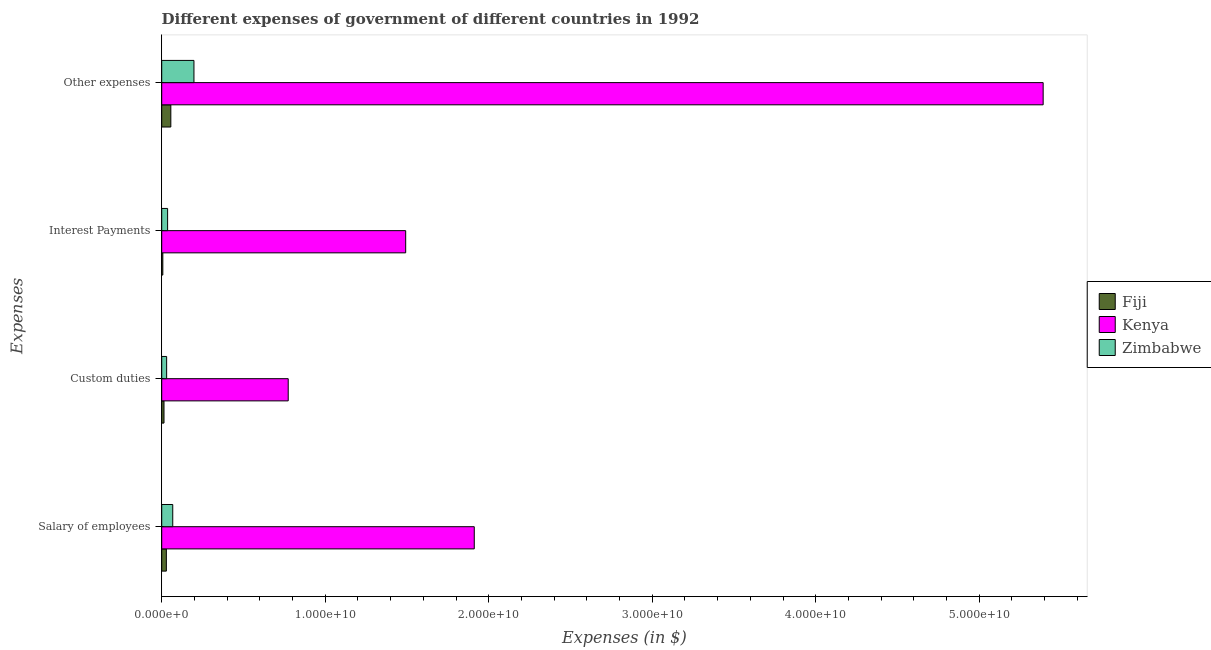How many different coloured bars are there?
Your response must be concise. 3. How many bars are there on the 3rd tick from the top?
Ensure brevity in your answer.  3. How many bars are there on the 4th tick from the bottom?
Provide a short and direct response. 3. What is the label of the 2nd group of bars from the top?
Offer a terse response. Interest Payments. What is the amount spent on other expenses in Fiji?
Your answer should be compact. 5.57e+08. Across all countries, what is the maximum amount spent on salary of employees?
Your response must be concise. 1.91e+1. Across all countries, what is the minimum amount spent on custom duties?
Give a very brief answer. 1.40e+08. In which country was the amount spent on interest payments maximum?
Ensure brevity in your answer.  Kenya. In which country was the amount spent on custom duties minimum?
Make the answer very short. Fiji. What is the total amount spent on salary of employees in the graph?
Your answer should be very brief. 2.01e+1. What is the difference between the amount spent on salary of employees in Zimbabwe and that in Kenya?
Keep it short and to the point. -1.84e+1. What is the difference between the amount spent on salary of employees in Zimbabwe and the amount spent on custom duties in Kenya?
Keep it short and to the point. -7.06e+09. What is the average amount spent on other expenses per country?
Provide a succinct answer. 1.88e+1. What is the difference between the amount spent on interest payments and amount spent on salary of employees in Kenya?
Your answer should be compact. -4.20e+09. In how many countries, is the amount spent on other expenses greater than 28000000000 $?
Give a very brief answer. 1. What is the ratio of the amount spent on salary of employees in Kenya to that in Fiji?
Offer a very short reply. 67.35. What is the difference between the highest and the second highest amount spent on other expenses?
Your answer should be very brief. 5.19e+1. What is the difference between the highest and the lowest amount spent on custom duties?
Your response must be concise. 7.60e+09. Is it the case that in every country, the sum of the amount spent on other expenses and amount spent on custom duties is greater than the sum of amount spent on salary of employees and amount spent on interest payments?
Your answer should be very brief. No. What does the 3rd bar from the top in Other expenses represents?
Offer a very short reply. Fiji. What does the 2nd bar from the bottom in Other expenses represents?
Provide a succinct answer. Kenya. Are all the bars in the graph horizontal?
Your answer should be very brief. Yes. How many countries are there in the graph?
Your answer should be compact. 3. What is the difference between two consecutive major ticks on the X-axis?
Make the answer very short. 1.00e+1. How many legend labels are there?
Your answer should be very brief. 3. How are the legend labels stacked?
Ensure brevity in your answer.  Vertical. What is the title of the graph?
Your answer should be very brief. Different expenses of government of different countries in 1992. What is the label or title of the X-axis?
Ensure brevity in your answer.  Expenses (in $). What is the label or title of the Y-axis?
Offer a very short reply. Expenses. What is the Expenses (in $) of Fiji in Salary of employees?
Provide a succinct answer. 2.84e+08. What is the Expenses (in $) of Kenya in Salary of employees?
Make the answer very short. 1.91e+1. What is the Expenses (in $) of Zimbabwe in Salary of employees?
Make the answer very short. 6.75e+08. What is the Expenses (in $) of Fiji in Custom duties?
Offer a very short reply. 1.40e+08. What is the Expenses (in $) in Kenya in Custom duties?
Provide a short and direct response. 7.74e+09. What is the Expenses (in $) in Zimbabwe in Custom duties?
Ensure brevity in your answer.  3.02e+08. What is the Expenses (in $) in Fiji in Interest Payments?
Give a very brief answer. 6.79e+07. What is the Expenses (in $) in Kenya in Interest Payments?
Keep it short and to the point. 1.49e+1. What is the Expenses (in $) of Zimbabwe in Interest Payments?
Your response must be concise. 3.61e+08. What is the Expenses (in $) of Fiji in Other expenses?
Your answer should be compact. 5.57e+08. What is the Expenses (in $) of Kenya in Other expenses?
Give a very brief answer. 5.39e+1. What is the Expenses (in $) of Zimbabwe in Other expenses?
Offer a very short reply. 1.97e+09. Across all Expenses, what is the maximum Expenses (in $) of Fiji?
Your answer should be very brief. 5.57e+08. Across all Expenses, what is the maximum Expenses (in $) of Kenya?
Ensure brevity in your answer.  5.39e+1. Across all Expenses, what is the maximum Expenses (in $) of Zimbabwe?
Your answer should be very brief. 1.97e+09. Across all Expenses, what is the minimum Expenses (in $) of Fiji?
Offer a very short reply. 6.79e+07. Across all Expenses, what is the minimum Expenses (in $) in Kenya?
Offer a very short reply. 7.74e+09. Across all Expenses, what is the minimum Expenses (in $) in Zimbabwe?
Give a very brief answer. 3.02e+08. What is the total Expenses (in $) in Fiji in the graph?
Your answer should be very brief. 1.05e+09. What is the total Expenses (in $) of Kenya in the graph?
Give a very brief answer. 9.57e+1. What is the total Expenses (in $) of Zimbabwe in the graph?
Offer a very short reply. 3.31e+09. What is the difference between the Expenses (in $) of Fiji in Salary of employees and that in Custom duties?
Offer a terse response. 1.44e+08. What is the difference between the Expenses (in $) of Kenya in Salary of employees and that in Custom duties?
Give a very brief answer. 1.14e+1. What is the difference between the Expenses (in $) in Zimbabwe in Salary of employees and that in Custom duties?
Your response must be concise. 3.73e+08. What is the difference between the Expenses (in $) in Fiji in Salary of employees and that in Interest Payments?
Give a very brief answer. 2.16e+08. What is the difference between the Expenses (in $) in Kenya in Salary of employees and that in Interest Payments?
Provide a succinct answer. 4.20e+09. What is the difference between the Expenses (in $) in Zimbabwe in Salary of employees and that in Interest Payments?
Make the answer very short. 3.14e+08. What is the difference between the Expenses (in $) in Fiji in Salary of employees and that in Other expenses?
Offer a very short reply. -2.74e+08. What is the difference between the Expenses (in $) in Kenya in Salary of employees and that in Other expenses?
Your answer should be very brief. -3.48e+1. What is the difference between the Expenses (in $) in Zimbabwe in Salary of employees and that in Other expenses?
Provide a succinct answer. -1.30e+09. What is the difference between the Expenses (in $) of Fiji in Custom duties and that in Interest Payments?
Ensure brevity in your answer.  7.24e+07. What is the difference between the Expenses (in $) in Kenya in Custom duties and that in Interest Payments?
Offer a very short reply. -7.18e+09. What is the difference between the Expenses (in $) of Zimbabwe in Custom duties and that in Interest Payments?
Provide a short and direct response. -5.88e+07. What is the difference between the Expenses (in $) of Fiji in Custom duties and that in Other expenses?
Offer a very short reply. -4.17e+08. What is the difference between the Expenses (in $) in Kenya in Custom duties and that in Other expenses?
Offer a terse response. -4.62e+1. What is the difference between the Expenses (in $) in Zimbabwe in Custom duties and that in Other expenses?
Your response must be concise. -1.67e+09. What is the difference between the Expenses (in $) of Fiji in Interest Payments and that in Other expenses?
Your answer should be compact. -4.90e+08. What is the difference between the Expenses (in $) in Kenya in Interest Payments and that in Other expenses?
Keep it short and to the point. -3.90e+1. What is the difference between the Expenses (in $) in Zimbabwe in Interest Payments and that in Other expenses?
Give a very brief answer. -1.61e+09. What is the difference between the Expenses (in $) of Fiji in Salary of employees and the Expenses (in $) of Kenya in Custom duties?
Ensure brevity in your answer.  -7.45e+09. What is the difference between the Expenses (in $) of Fiji in Salary of employees and the Expenses (in $) of Zimbabwe in Custom duties?
Your response must be concise. -1.80e+07. What is the difference between the Expenses (in $) in Kenya in Salary of employees and the Expenses (in $) in Zimbabwe in Custom duties?
Your answer should be very brief. 1.88e+1. What is the difference between the Expenses (in $) in Fiji in Salary of employees and the Expenses (in $) in Kenya in Interest Payments?
Make the answer very short. -1.46e+1. What is the difference between the Expenses (in $) in Fiji in Salary of employees and the Expenses (in $) in Zimbabwe in Interest Payments?
Offer a terse response. -7.68e+07. What is the difference between the Expenses (in $) in Kenya in Salary of employees and the Expenses (in $) in Zimbabwe in Interest Payments?
Your answer should be compact. 1.88e+1. What is the difference between the Expenses (in $) of Fiji in Salary of employees and the Expenses (in $) of Kenya in Other expenses?
Keep it short and to the point. -5.36e+1. What is the difference between the Expenses (in $) of Fiji in Salary of employees and the Expenses (in $) of Zimbabwe in Other expenses?
Provide a short and direct response. -1.69e+09. What is the difference between the Expenses (in $) of Kenya in Salary of employees and the Expenses (in $) of Zimbabwe in Other expenses?
Your answer should be compact. 1.71e+1. What is the difference between the Expenses (in $) of Fiji in Custom duties and the Expenses (in $) of Kenya in Interest Payments?
Provide a succinct answer. -1.48e+1. What is the difference between the Expenses (in $) of Fiji in Custom duties and the Expenses (in $) of Zimbabwe in Interest Payments?
Make the answer very short. -2.20e+08. What is the difference between the Expenses (in $) in Kenya in Custom duties and the Expenses (in $) in Zimbabwe in Interest Payments?
Your answer should be compact. 7.38e+09. What is the difference between the Expenses (in $) in Fiji in Custom duties and the Expenses (in $) in Kenya in Other expenses?
Make the answer very short. -5.38e+1. What is the difference between the Expenses (in $) in Fiji in Custom duties and the Expenses (in $) in Zimbabwe in Other expenses?
Make the answer very short. -1.83e+09. What is the difference between the Expenses (in $) in Kenya in Custom duties and the Expenses (in $) in Zimbabwe in Other expenses?
Ensure brevity in your answer.  5.77e+09. What is the difference between the Expenses (in $) in Fiji in Interest Payments and the Expenses (in $) in Kenya in Other expenses?
Ensure brevity in your answer.  -5.38e+1. What is the difference between the Expenses (in $) in Fiji in Interest Payments and the Expenses (in $) in Zimbabwe in Other expenses?
Offer a terse response. -1.90e+09. What is the difference between the Expenses (in $) in Kenya in Interest Payments and the Expenses (in $) in Zimbabwe in Other expenses?
Give a very brief answer. 1.29e+1. What is the average Expenses (in $) in Fiji per Expenses?
Make the answer very short. 2.62e+08. What is the average Expenses (in $) in Kenya per Expenses?
Your answer should be very brief. 2.39e+1. What is the average Expenses (in $) of Zimbabwe per Expenses?
Your answer should be very brief. 8.27e+08. What is the difference between the Expenses (in $) in Fiji and Expenses (in $) in Kenya in Salary of employees?
Offer a terse response. -1.88e+1. What is the difference between the Expenses (in $) in Fiji and Expenses (in $) in Zimbabwe in Salary of employees?
Your answer should be compact. -3.91e+08. What is the difference between the Expenses (in $) of Kenya and Expenses (in $) of Zimbabwe in Salary of employees?
Give a very brief answer. 1.84e+1. What is the difference between the Expenses (in $) in Fiji and Expenses (in $) in Kenya in Custom duties?
Provide a succinct answer. -7.60e+09. What is the difference between the Expenses (in $) in Fiji and Expenses (in $) in Zimbabwe in Custom duties?
Your response must be concise. -1.62e+08. What is the difference between the Expenses (in $) of Kenya and Expenses (in $) of Zimbabwe in Custom duties?
Your response must be concise. 7.44e+09. What is the difference between the Expenses (in $) of Fiji and Expenses (in $) of Kenya in Interest Payments?
Keep it short and to the point. -1.49e+1. What is the difference between the Expenses (in $) in Fiji and Expenses (in $) in Zimbabwe in Interest Payments?
Your response must be concise. -2.93e+08. What is the difference between the Expenses (in $) of Kenya and Expenses (in $) of Zimbabwe in Interest Payments?
Your answer should be very brief. 1.46e+1. What is the difference between the Expenses (in $) in Fiji and Expenses (in $) in Kenya in Other expenses?
Offer a very short reply. -5.34e+1. What is the difference between the Expenses (in $) in Fiji and Expenses (in $) in Zimbabwe in Other expenses?
Keep it short and to the point. -1.41e+09. What is the difference between the Expenses (in $) of Kenya and Expenses (in $) of Zimbabwe in Other expenses?
Your answer should be very brief. 5.19e+1. What is the ratio of the Expenses (in $) in Fiji in Salary of employees to that in Custom duties?
Keep it short and to the point. 2.02. What is the ratio of the Expenses (in $) in Kenya in Salary of employees to that in Custom duties?
Your answer should be very brief. 2.47. What is the ratio of the Expenses (in $) in Zimbabwe in Salary of employees to that in Custom duties?
Provide a short and direct response. 2.24. What is the ratio of the Expenses (in $) in Fiji in Salary of employees to that in Interest Payments?
Make the answer very short. 4.18. What is the ratio of the Expenses (in $) of Kenya in Salary of employees to that in Interest Payments?
Make the answer very short. 1.28. What is the ratio of the Expenses (in $) in Zimbabwe in Salary of employees to that in Interest Payments?
Your response must be concise. 1.87. What is the ratio of the Expenses (in $) in Fiji in Salary of employees to that in Other expenses?
Your answer should be compact. 0.51. What is the ratio of the Expenses (in $) of Kenya in Salary of employees to that in Other expenses?
Offer a terse response. 0.35. What is the ratio of the Expenses (in $) in Zimbabwe in Salary of employees to that in Other expenses?
Provide a succinct answer. 0.34. What is the ratio of the Expenses (in $) of Fiji in Custom duties to that in Interest Payments?
Make the answer very short. 2.07. What is the ratio of the Expenses (in $) of Kenya in Custom duties to that in Interest Payments?
Offer a very short reply. 0.52. What is the ratio of the Expenses (in $) in Zimbabwe in Custom duties to that in Interest Payments?
Keep it short and to the point. 0.84. What is the ratio of the Expenses (in $) in Fiji in Custom duties to that in Other expenses?
Make the answer very short. 0.25. What is the ratio of the Expenses (in $) of Kenya in Custom duties to that in Other expenses?
Your answer should be very brief. 0.14. What is the ratio of the Expenses (in $) of Zimbabwe in Custom duties to that in Other expenses?
Offer a very short reply. 0.15. What is the ratio of the Expenses (in $) of Fiji in Interest Payments to that in Other expenses?
Offer a very short reply. 0.12. What is the ratio of the Expenses (in $) of Kenya in Interest Payments to that in Other expenses?
Your response must be concise. 0.28. What is the ratio of the Expenses (in $) in Zimbabwe in Interest Payments to that in Other expenses?
Give a very brief answer. 0.18. What is the difference between the highest and the second highest Expenses (in $) in Fiji?
Offer a terse response. 2.74e+08. What is the difference between the highest and the second highest Expenses (in $) in Kenya?
Keep it short and to the point. 3.48e+1. What is the difference between the highest and the second highest Expenses (in $) of Zimbabwe?
Your answer should be very brief. 1.30e+09. What is the difference between the highest and the lowest Expenses (in $) of Fiji?
Offer a very short reply. 4.90e+08. What is the difference between the highest and the lowest Expenses (in $) of Kenya?
Offer a terse response. 4.62e+1. What is the difference between the highest and the lowest Expenses (in $) of Zimbabwe?
Ensure brevity in your answer.  1.67e+09. 